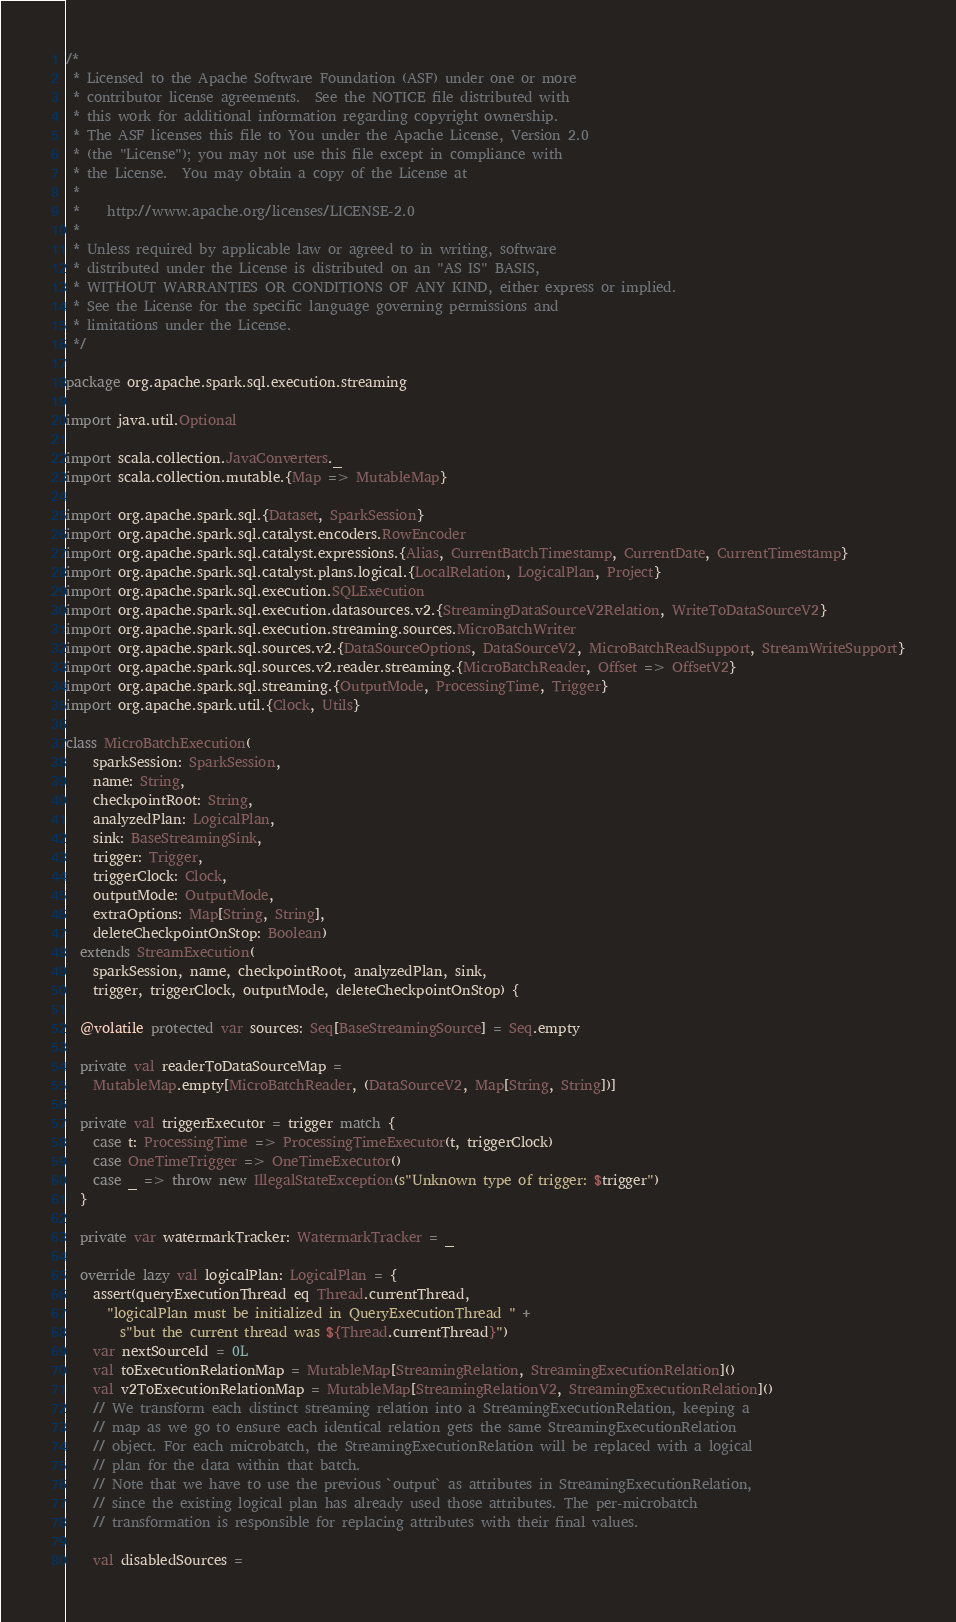Convert code to text. <code><loc_0><loc_0><loc_500><loc_500><_Scala_>/*
 * Licensed to the Apache Software Foundation (ASF) under one or more
 * contributor license agreements.  See the NOTICE file distributed with
 * this work for additional information regarding copyright ownership.
 * The ASF licenses this file to You under the Apache License, Version 2.0
 * (the "License"); you may not use this file except in compliance with
 * the License.  You may obtain a copy of the License at
 *
 *    http://www.apache.org/licenses/LICENSE-2.0
 *
 * Unless required by applicable law or agreed to in writing, software
 * distributed under the License is distributed on an "AS IS" BASIS,
 * WITHOUT WARRANTIES OR CONDITIONS OF ANY KIND, either express or implied.
 * See the License for the specific language governing permissions and
 * limitations under the License.
 */

package org.apache.spark.sql.execution.streaming

import java.util.Optional

import scala.collection.JavaConverters._
import scala.collection.mutable.{Map => MutableMap}

import org.apache.spark.sql.{Dataset, SparkSession}
import org.apache.spark.sql.catalyst.encoders.RowEncoder
import org.apache.spark.sql.catalyst.expressions.{Alias, CurrentBatchTimestamp, CurrentDate, CurrentTimestamp}
import org.apache.spark.sql.catalyst.plans.logical.{LocalRelation, LogicalPlan, Project}
import org.apache.spark.sql.execution.SQLExecution
import org.apache.spark.sql.execution.datasources.v2.{StreamingDataSourceV2Relation, WriteToDataSourceV2}
import org.apache.spark.sql.execution.streaming.sources.MicroBatchWriter
import org.apache.spark.sql.sources.v2.{DataSourceOptions, DataSourceV2, MicroBatchReadSupport, StreamWriteSupport}
import org.apache.spark.sql.sources.v2.reader.streaming.{MicroBatchReader, Offset => OffsetV2}
import org.apache.spark.sql.streaming.{OutputMode, ProcessingTime, Trigger}
import org.apache.spark.util.{Clock, Utils}

class MicroBatchExecution(
    sparkSession: SparkSession,
    name: String,
    checkpointRoot: String,
    analyzedPlan: LogicalPlan,
    sink: BaseStreamingSink,
    trigger: Trigger,
    triggerClock: Clock,
    outputMode: OutputMode,
    extraOptions: Map[String, String],
    deleteCheckpointOnStop: Boolean)
  extends StreamExecution(
    sparkSession, name, checkpointRoot, analyzedPlan, sink,
    trigger, triggerClock, outputMode, deleteCheckpointOnStop) {

  @volatile protected var sources: Seq[BaseStreamingSource] = Seq.empty

  private val readerToDataSourceMap =
    MutableMap.empty[MicroBatchReader, (DataSourceV2, Map[String, String])]

  private val triggerExecutor = trigger match {
    case t: ProcessingTime => ProcessingTimeExecutor(t, triggerClock)
    case OneTimeTrigger => OneTimeExecutor()
    case _ => throw new IllegalStateException(s"Unknown type of trigger: $trigger")
  }

  private var watermarkTracker: WatermarkTracker = _

  override lazy val logicalPlan: LogicalPlan = {
    assert(queryExecutionThread eq Thread.currentThread,
      "logicalPlan must be initialized in QueryExecutionThread " +
        s"but the current thread was ${Thread.currentThread}")
    var nextSourceId = 0L
    val toExecutionRelationMap = MutableMap[StreamingRelation, StreamingExecutionRelation]()
    val v2ToExecutionRelationMap = MutableMap[StreamingRelationV2, StreamingExecutionRelation]()
    // We transform each distinct streaming relation into a StreamingExecutionRelation, keeping a
    // map as we go to ensure each identical relation gets the same StreamingExecutionRelation
    // object. For each microbatch, the StreamingExecutionRelation will be replaced with a logical
    // plan for the data within that batch.
    // Note that we have to use the previous `output` as attributes in StreamingExecutionRelation,
    // since the existing logical plan has already used those attributes. The per-microbatch
    // transformation is responsible for replacing attributes with their final values.

    val disabledSources =</code> 